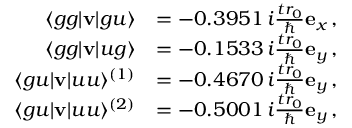Convert formula to latex. <formula><loc_0><loc_0><loc_500><loc_500>\begin{array} { r l } { \langle g g | { v } | g u \rangle } & { = - 0 . 3 9 5 1 \, i \frac { t r _ { 0 } } { } { e } _ { x } \, , } \\ { \langle g g | { v } | u g \rangle } & { = - 0 . 1 5 3 3 \, i \frac { t r _ { 0 } } { } { e } _ { y } \, , } \\ { \langle g u | { v } | u u \rangle ^ { ( 1 ) } } & { = - 0 . 4 6 7 0 \, i \frac { t r _ { 0 } } { } { e } _ { y } \, , } \\ { \langle g u | { v } | u u \rangle ^ { ( 2 ) } } & { = - 0 . 5 0 0 1 \, i \frac { t r _ { 0 } } { } { e } _ { y } \, , } \end{array}</formula> 